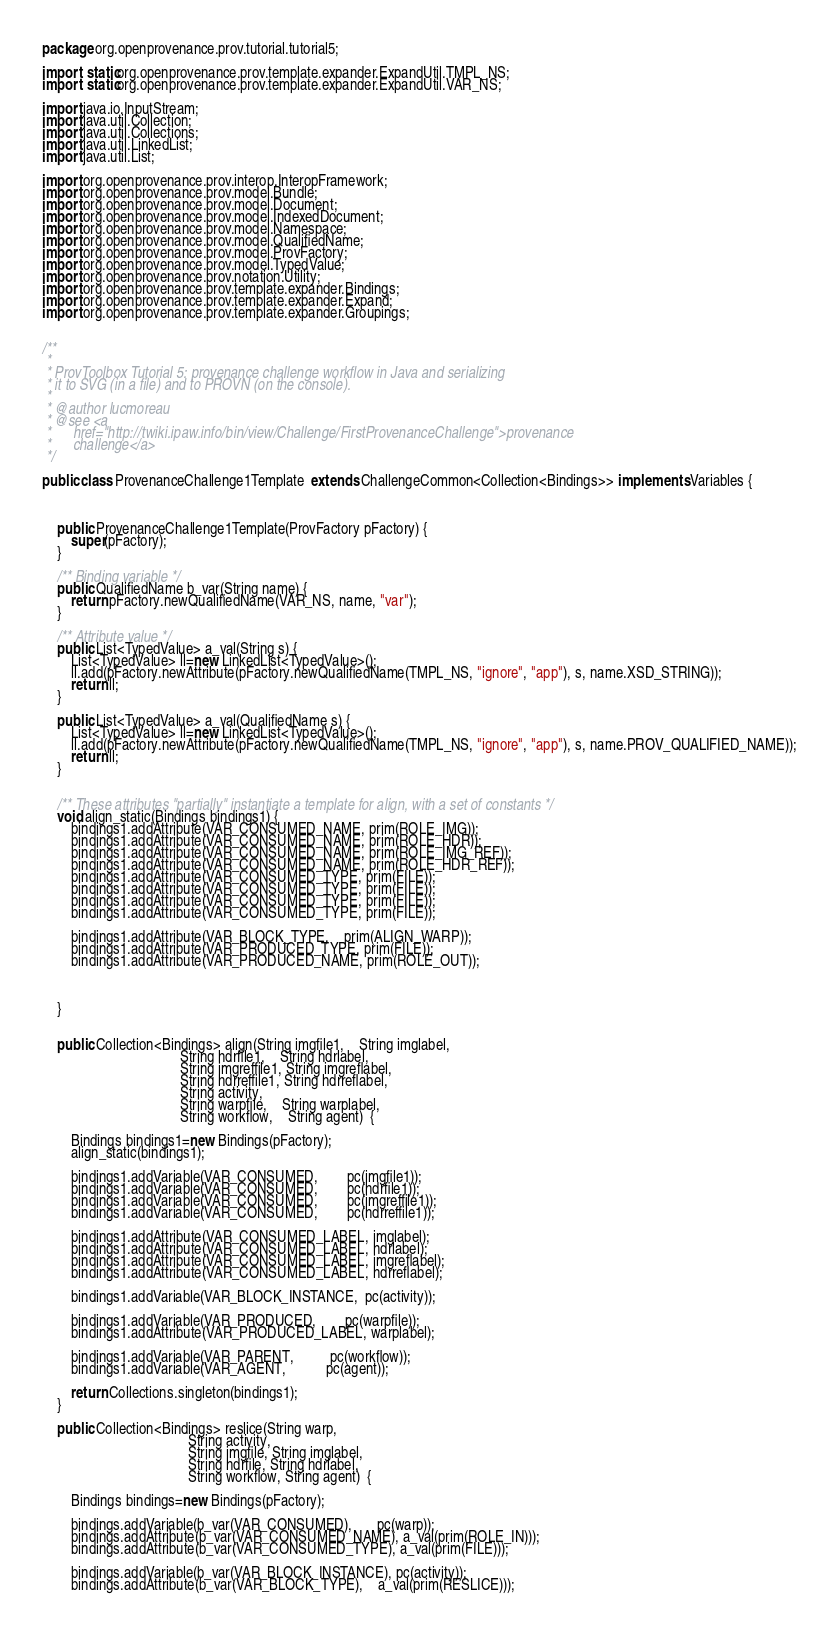Convert code to text. <code><loc_0><loc_0><loc_500><loc_500><_Java_>package org.openprovenance.prov.tutorial.tutorial5;

import static org.openprovenance.prov.template.expander.ExpandUtil.TMPL_NS;
import static org.openprovenance.prov.template.expander.ExpandUtil.VAR_NS;

import java.io.InputStream;
import java.util.Collection;
import java.util.Collections;
import java.util.LinkedList;
import java.util.List;

import org.openprovenance.prov.interop.InteropFramework;
import org.openprovenance.prov.model.Bundle;
import org.openprovenance.prov.model.Document;
import org.openprovenance.prov.model.IndexedDocument;
import org.openprovenance.prov.model.Namespace;
import org.openprovenance.prov.model.QualifiedName;
import org.openprovenance.prov.model.ProvFactory;
import org.openprovenance.prov.model.TypedValue;
import org.openprovenance.prov.notation.Utility;
import org.openprovenance.prov.template.expander.Bindings;
import org.openprovenance.prov.template.expander.Expand;
import org.openprovenance.prov.template.expander.Groupings;


/**
 * 
 * ProvToolbox Tutorial 5: provenance challenge workflow in Java and serializing
 * it to SVG (in a file) and to PROVN (on the console).
 * 
 * @author lucmoreau
 * @see <a
 *      href="http://twiki.ipaw.info/bin/view/Challenge/FirstProvenanceChallenge">provenance
 *      challenge</a>
 */

public class ProvenanceChallenge1Template  extends ChallengeCommon<Collection<Bindings>> implements Variables {   



    public ProvenanceChallenge1Template(ProvFactory pFactory) {
        super(pFactory);
    }

    /** Binding variable */
    public QualifiedName b_var(String name) {
        return pFactory.newQualifiedName(VAR_NS, name, "var");
    }

    /** Attribute value */
    public List<TypedValue> a_val(String s) {
        List<TypedValue> ll=new LinkedList<TypedValue>();
        ll.add(pFactory.newAttribute(pFactory.newQualifiedName(TMPL_NS, "ignore", "app"), s, name.XSD_STRING));
        return ll;
    }
    
    public List<TypedValue> a_val(QualifiedName s) {
        List<TypedValue> ll=new LinkedList<TypedValue>();
        ll.add(pFactory.newAttribute(pFactory.newQualifiedName(TMPL_NS, "ignore", "app"), s, name.PROV_QUALIFIED_NAME));
        return ll;
    }
    
    
    /** These attributes "partially" instantiate a template for align, with a set of constants */
    void align_static(Bindings bindings1) {
        bindings1.addAttribute(VAR_CONSUMED_NAME, prim(ROLE_IMG));
        bindings1.addAttribute(VAR_CONSUMED_NAME, prim(ROLE_HDR));
        bindings1.addAttribute(VAR_CONSUMED_NAME, prim(ROLE_IMG_REF));
        bindings1.addAttribute(VAR_CONSUMED_NAME, prim(ROLE_HDR_REF));     
        bindings1.addAttribute(VAR_CONSUMED_TYPE, prim(FILE));
        bindings1.addAttribute(VAR_CONSUMED_TYPE, prim(FILE));
        bindings1.addAttribute(VAR_CONSUMED_TYPE, prim(FILE));
        bindings1.addAttribute(VAR_CONSUMED_TYPE, prim(FILE));
        
        bindings1.addAttribute(VAR_BLOCK_TYPE,    prim(ALIGN_WARP));
        bindings1.addAttribute(VAR_PRODUCED_TYPE, prim(FILE));
        bindings1.addAttribute(VAR_PRODUCED_NAME, prim(ROLE_OUT));


        
    }

  
    public Collection<Bindings> align(String imgfile1,    String imglabel, 
                                      String hdrfile1,    String hdrlabel,
                                      String imgreffile1, String imgreflabel, 
                                      String hdrreffile1, String hdrreflabel, 
                                      String activity, 
                                      String warpfile,    String warplabel,
                                      String workflow,    String agent)  {
	
        Bindings bindings1=new Bindings(pFactory);
        align_static(bindings1);
        
        bindings1.addVariable(VAR_CONSUMED,        pc(imgfile1));
        bindings1.addVariable(VAR_CONSUMED,        pc(hdrfile1));      
        bindings1.addVariable(VAR_CONSUMED,        pc(imgreffile1));
        bindings1.addVariable(VAR_CONSUMED,        pc(hdrreffile1));      

        bindings1.addAttribute(VAR_CONSUMED_LABEL, imglabel);
        bindings1.addAttribute(VAR_CONSUMED_LABEL, hdrlabel);
        bindings1.addAttribute(VAR_CONSUMED_LABEL, imgreflabel);
        bindings1.addAttribute(VAR_CONSUMED_LABEL, hdrreflabel);
        
        bindings1.addVariable(VAR_BLOCK_INSTANCE,  pc(activity));      
   
        bindings1.addVariable(VAR_PRODUCED,        pc(warpfile));      
        bindings1.addAttribute(VAR_PRODUCED_LABEL, warplabel);
        
        bindings1.addVariable(VAR_PARENT,          pc(workflow));      
        bindings1.addVariable(VAR_AGENT,           pc(agent));      
        
        return Collections.singleton(bindings1);
    }
    
    public Collection<Bindings> reslice(String warp, 
                                        String activity, 
                                        String imgfile, String imglabel,
                                        String hdrfile, String hdrlabel,
                                        String workflow, String agent)  {
    
        Bindings bindings=new Bindings(pFactory);
        
        bindings.addVariable(b_var(VAR_CONSUMED),       pc(warp));
        bindings.addAttribute(b_var(VAR_CONSUMED_NAME), a_val(prim(ROLE_IN)));
        bindings.addAttribute(b_var(VAR_CONSUMED_TYPE), a_val(prim(FILE)));
        
        bindings.addVariable(b_var(VAR_BLOCK_INSTANCE), pc(activity));      
        bindings.addAttribute(b_var(VAR_BLOCK_TYPE),    a_val(prim(RESLICE)));
        </code> 